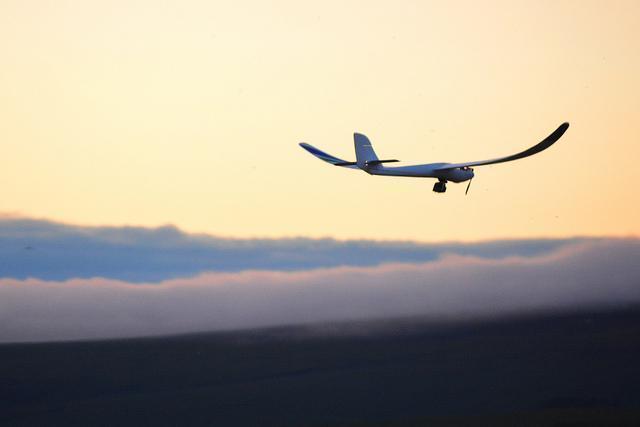How many airplanes are visible?
Give a very brief answer. 1. 